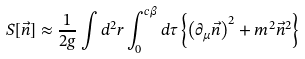<formula> <loc_0><loc_0><loc_500><loc_500>S [ \vec { n } ] \approx \frac { 1 } { 2 g } \int d ^ { 2 } r \int _ { 0 } ^ { c \beta } d \tau \left \{ \left ( \partial _ { \mu } \vec { n } \right ) ^ { 2 } + m ^ { 2 } \vec { n } ^ { 2 } \right \}</formula> 